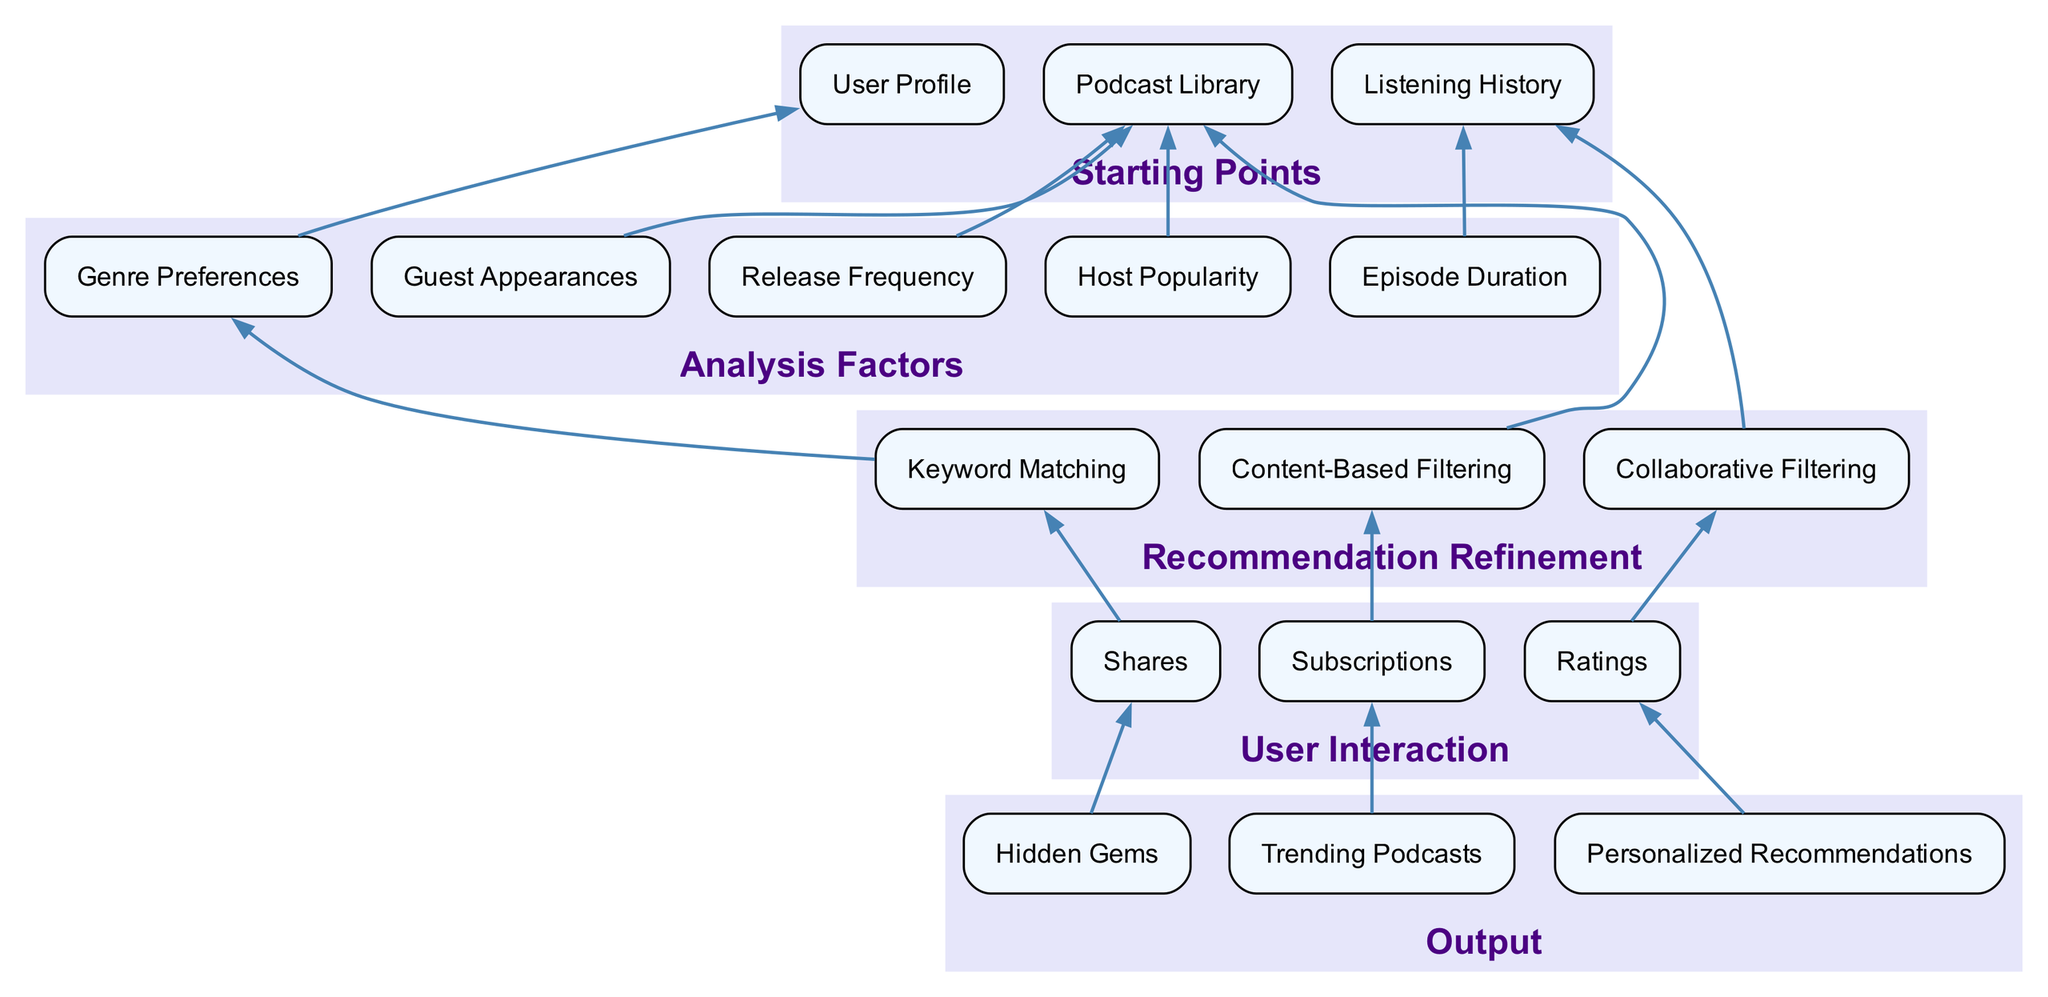What are the starting points in the diagram? The starting points are listed at the top of the diagram and include "User Profile", "Listening History", and "Podcast Library". These nodes represent the initial data sources for the recommendation process.
Answer: User Profile, Listening History, Podcast Library How many analysis factors are identified in the diagram? By counting the nodes under the "Analysis Factors" section, we see there are five factors: "Genre Preferences", "Episode Duration", "Release Frequency", "Host Popularity", and "Guest Appearances".
Answer: 5 What type of filtering is associated with "Keyword Matching"? In the diagram, "Keyword Matching" is connected to the "Genre Preferences" node, indicating it uses keyword matching to refine recommendations based on genre.
Answer: Genre Preferences Which user interaction influences "Collaborative Filtering"? The node "Ratings" is directly connected to "Collaborative Filtering" in the diagram, suggesting that user ratings play a key role in this recommendation method.
Answer: Ratings What is the output produced by the node "Subscriptions"? The output "Trending Podcasts" is connected to "Subscriptions", indicating that user subscriptions lead to the identification of trending podcasts.
Answer: Trending Podcasts Which recommendation refinement method is linked to "Listening History"? The diagram shows that "Collaborative Filtering" is connected to "Listening History", indicating that this method relies on the user's listening habits for recommendations.
Answer: Collaborative Filtering How many nodes are in the "User Interaction" section? The "User Interaction" category includes three nodes: "Ratings", "Subscriptions", and "Shares". Counting these gives us a total of three nodes.
Answer: 3 What are the outputs listed in the diagram? The outputs mentioned in the diagram are "Personalized Recommendations", "Trending Podcasts", and "Hidden Gems", each representing different result types from the recommendation process.
Answer: Personalized Recommendations, Trending Podcasts, Hidden Gems What does "Content-Based Filtering" use to make suggestions? "Content-Based Filtering" is connected to "Podcast Library", indicating that it utilizes the podcast library's contents to tailor recommendations.
Answer: Podcast Library 